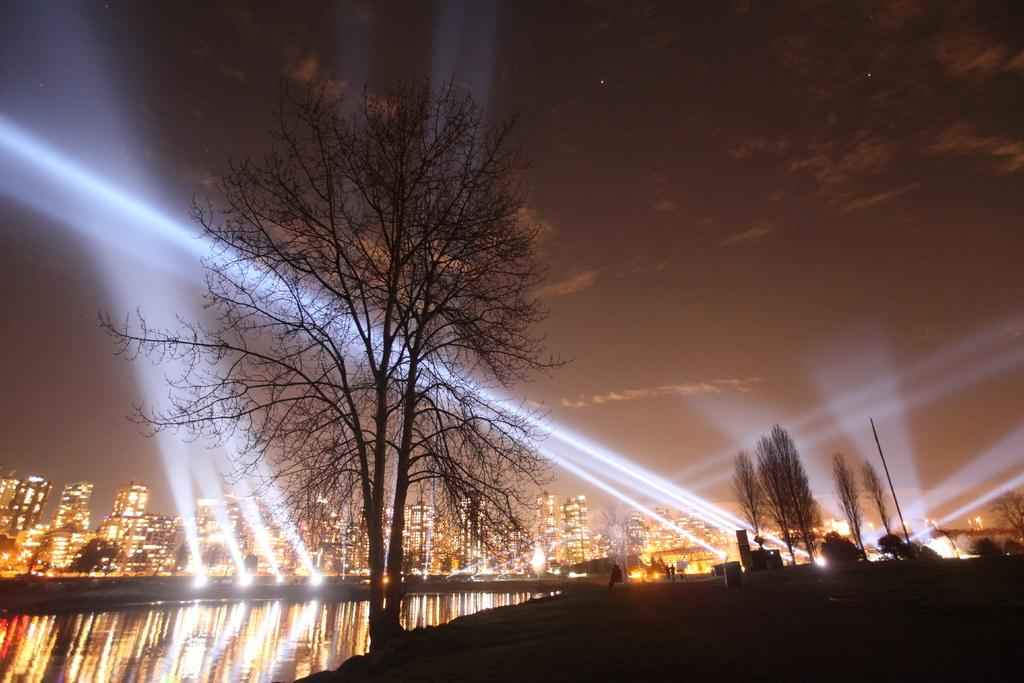What type of natural environment is present in the image? There are trees and a lake in the image. What can be seen in the background of the image? There are lights and a city with buildings in the background. What is the time of day depicted in the image? The sky in the image is of a night view. What type of meat is being grilled by the father in the image? There is no father or meat present in the image. Can you see a giraffe in the image? No, there is no giraffe in the image. 